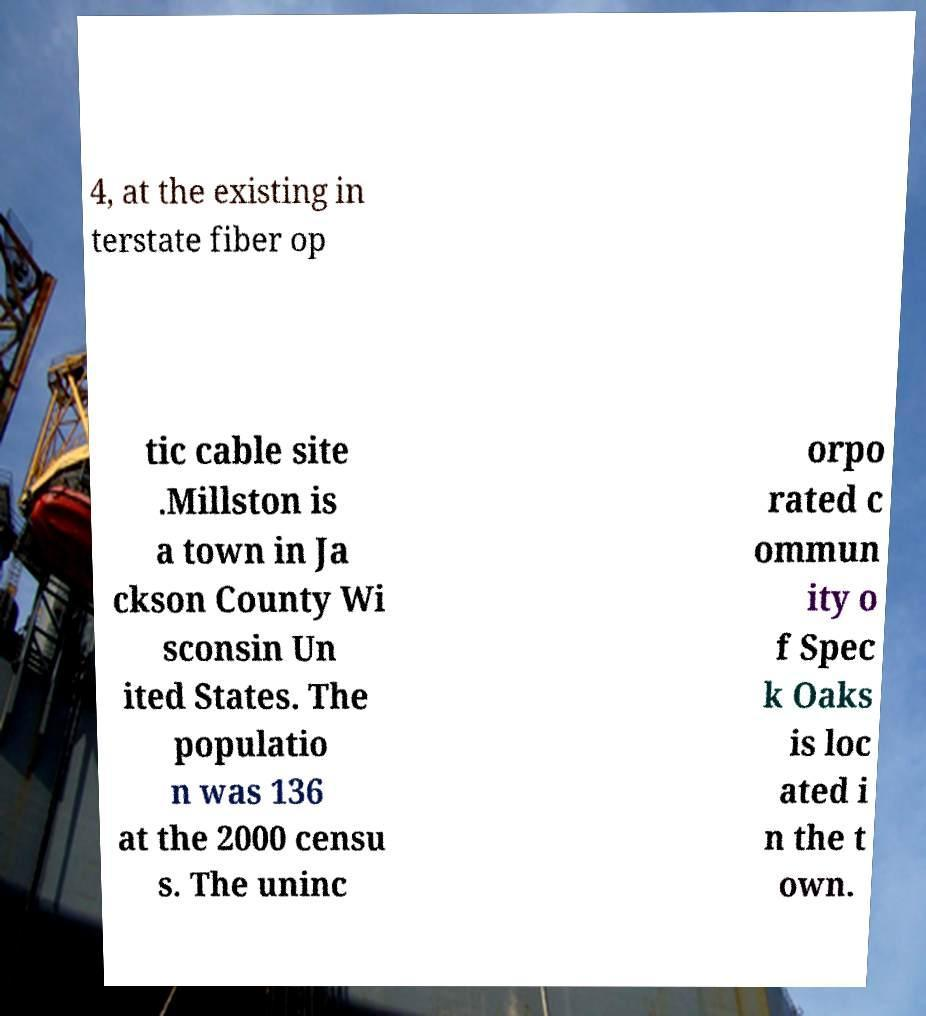Could you assist in decoding the text presented in this image and type it out clearly? 4, at the existing in terstate fiber op tic cable site .Millston is a town in Ja ckson County Wi sconsin Un ited States. The populatio n was 136 at the 2000 censu s. The uninc orpo rated c ommun ity o f Spec k Oaks is loc ated i n the t own. 